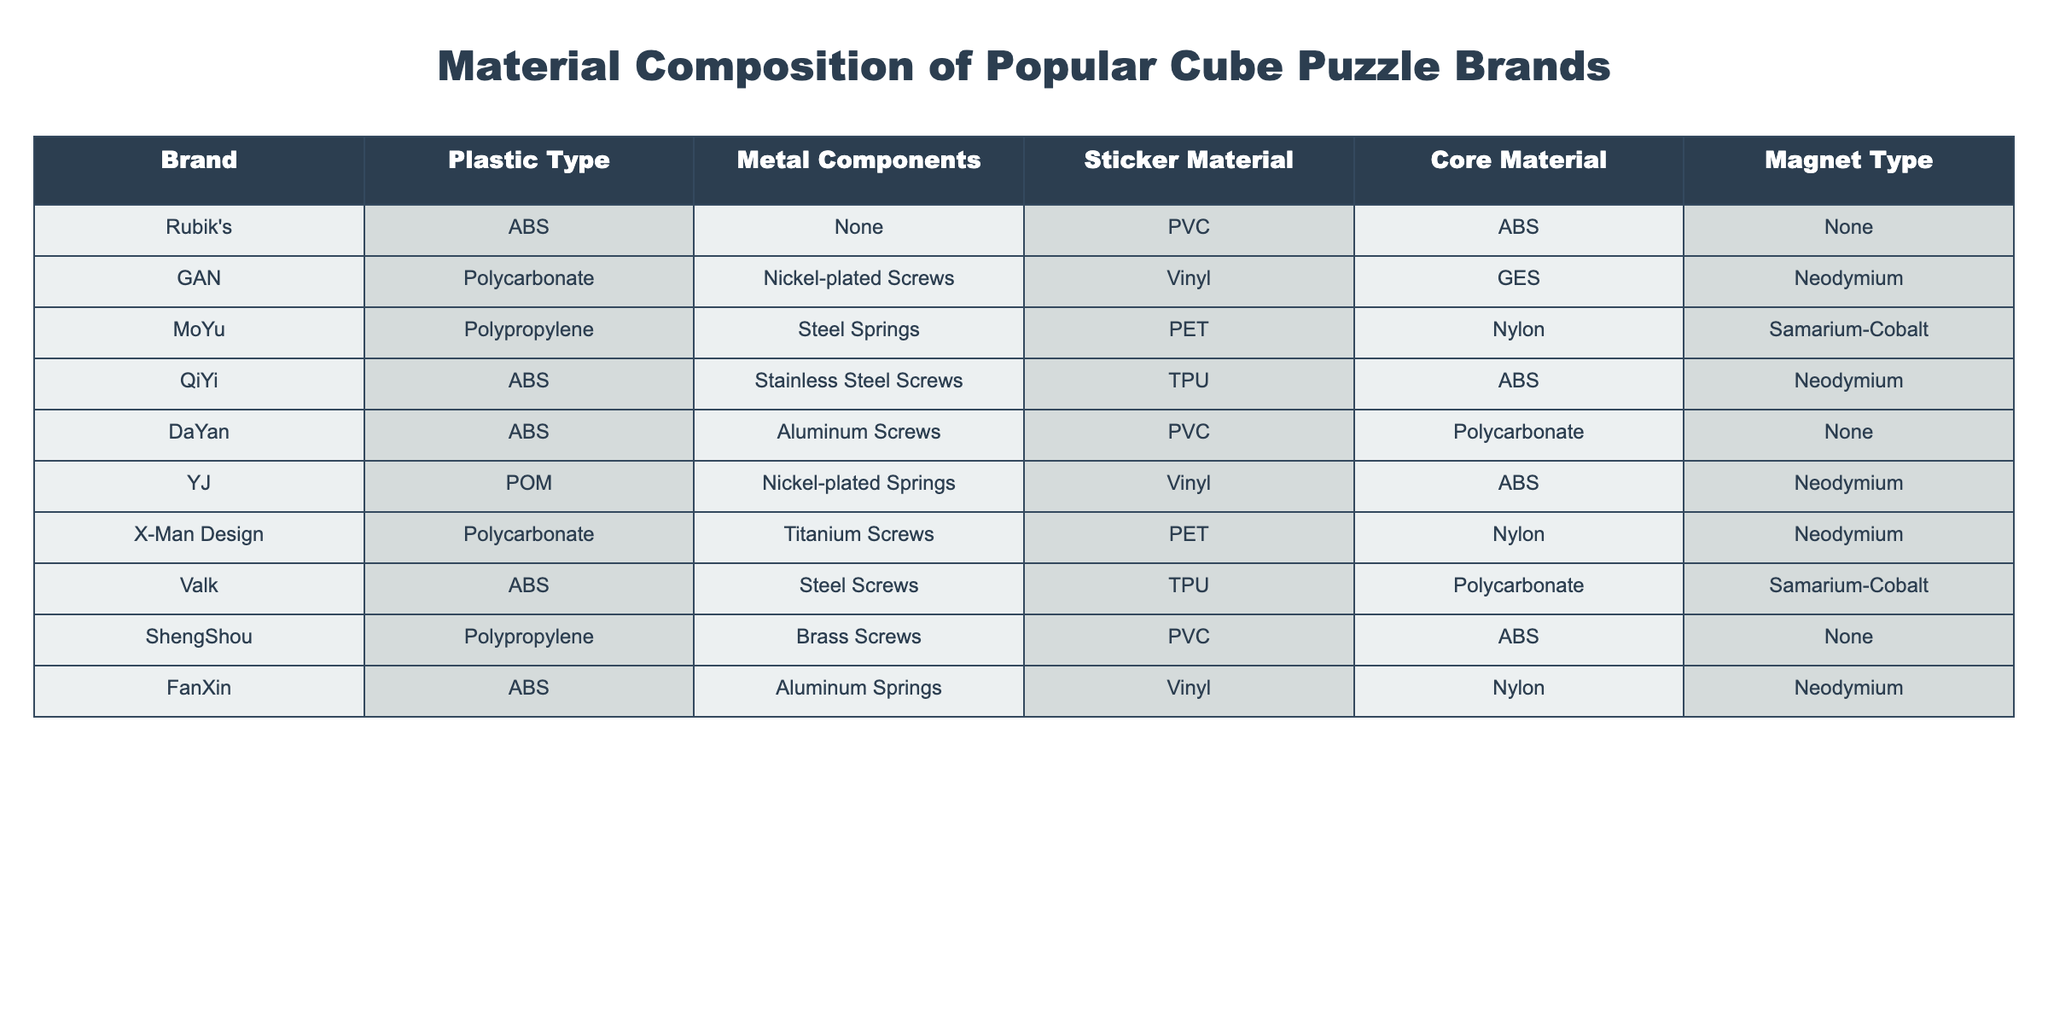What plastic type does the Rubik's brand use? By looking at the row for the Rubik's brand in the table, we can see that the plastic type listed is ABS.
Answer: ABS Which brand uses Neodymium magnets? From the table, we can identify several brands that have Neodymium listed as their magnet type: GAN, QiYi, YJ, X-Man Design, and FanXin.
Answer: GAN, QiYi, YJ, X-Man Design, FanXin How many brands use ABS as their core material? Checking the 'Core Material' column, we find that both Rubik's and QiYi use ABS as their core material. So there are 2 brands.
Answer: 2 Does ShengShou have any metal components? Looking at the 'Metal Components' column for the ShengShou brand, it shows 'Brass Screws', indicating that it does indeed have metal components.
Answer: Yes Which brand uses Aluminum screws and what is its sticker material? From the table, we see that both the DaYan and FanXin brands use aluminum screws. DaYan uses PVC as its sticker material, while FanXin uses Vinyl.
Answer: DaYan (PVC), FanXin (Vinyl) Which brand has the highest diversity in materials used? To analyze diversity, we can check how many unique material types each brand uses across the categories. X-Man Design uses 5 different material types (Polycarbonate, Titanium Screws, PET, Nylon, Neodymium).
Answer: X-Man Design What is the average number of different materials used by the brands? By counting the unique materials each brand uses (rubric being 5 types: Plastic, Metal, Sticker, Core, Magnet), we find that brands have the following counts: Rubik's (5), GAN (5), MoYu (5), QiYi (5), DaYan (5), YJ (5), X-Man Design (5), Valk (5), ShengShou (5), FanXin (5) which gives us an average of 5 since all brands use the same number.
Answer: 5 Is there any brand that does not use any metal components? Examining the table shows that Rubik's, DaYan, and ShengShou have 'None' listed under metal components, indicating they do not use any.
Answer: Yes How many brands use PVC as their sticker material? By checking the 'Sticker Material' column, we find that both Rubik's and ShengShou have PVC listed as their sticker material.
Answer: 2 Which brand does not use magnets at all? By looking in the 'Magnet Type' column, we can see that the brands Rubik's and DaYan have 'None' listed, meaning they do not use magnets.
Answer: Rubik's, DaYan 